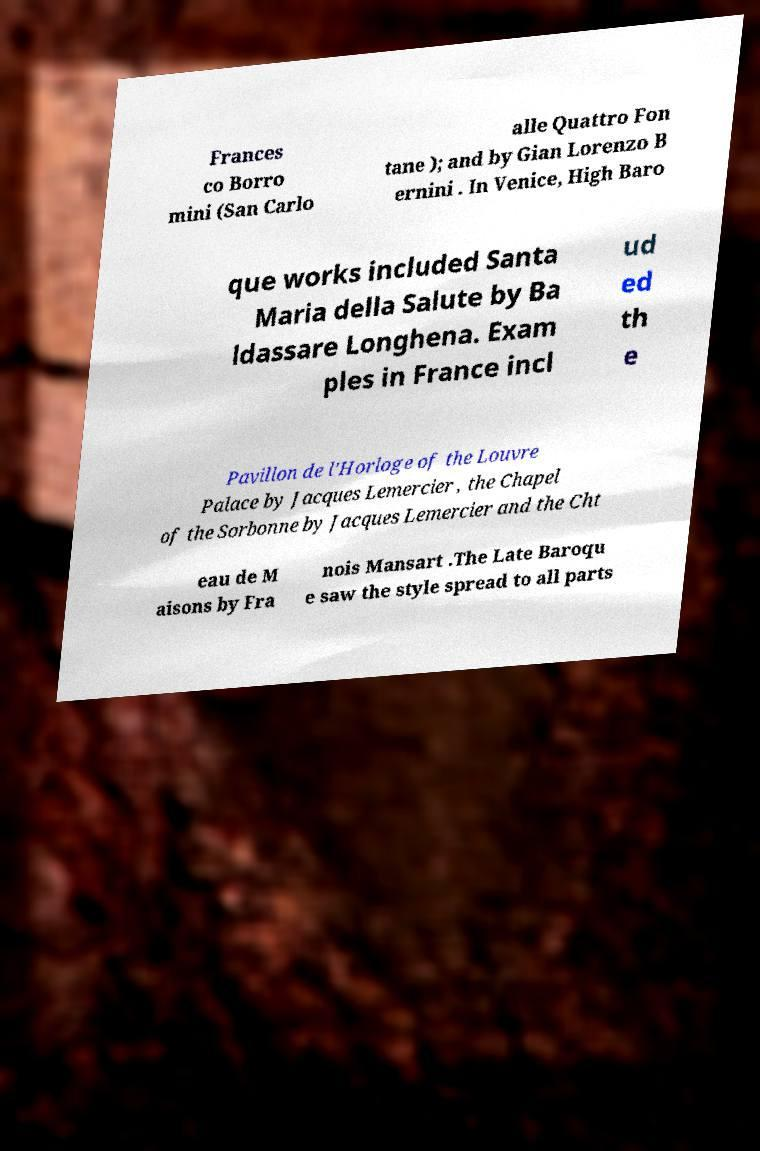I need the written content from this picture converted into text. Can you do that? Frances co Borro mini (San Carlo alle Quattro Fon tane ); and by Gian Lorenzo B ernini . In Venice, High Baro que works included Santa Maria della Salute by Ba ldassare Longhena. Exam ples in France incl ud ed th e Pavillon de l’Horloge of the Louvre Palace by Jacques Lemercier , the Chapel of the Sorbonne by Jacques Lemercier and the Cht eau de M aisons by Fra nois Mansart .The Late Baroqu e saw the style spread to all parts 